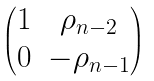Convert formula to latex. <formula><loc_0><loc_0><loc_500><loc_500>\begin{pmatrix} 1 & \rho _ { n - 2 } \\ 0 & - \rho _ { n - 1 } \end{pmatrix}</formula> 